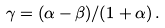<formula> <loc_0><loc_0><loc_500><loc_500>\gamma = ( \alpha - \beta ) / ( 1 + \alpha ) \, .</formula> 